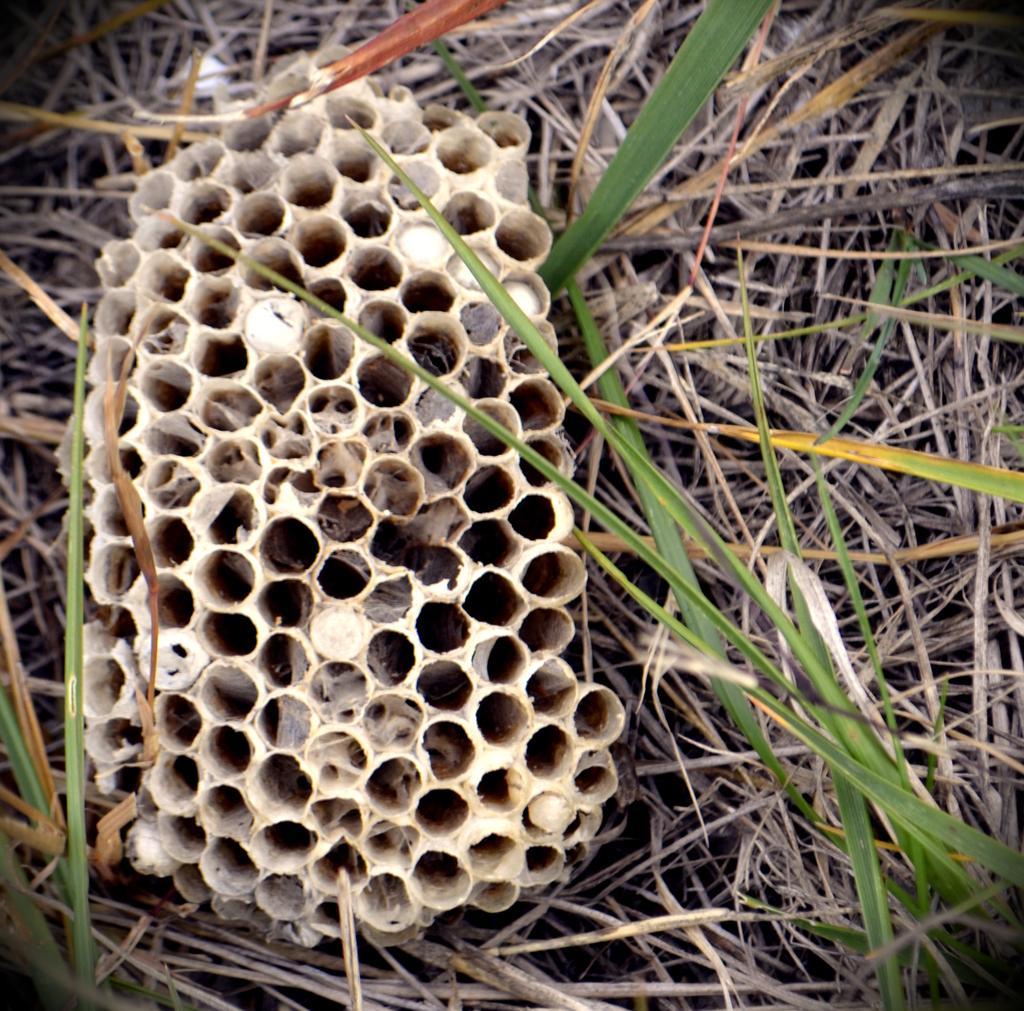How would you summarize this image in a sentence or two? In this image we can see honeycomb and some grasses around it. 